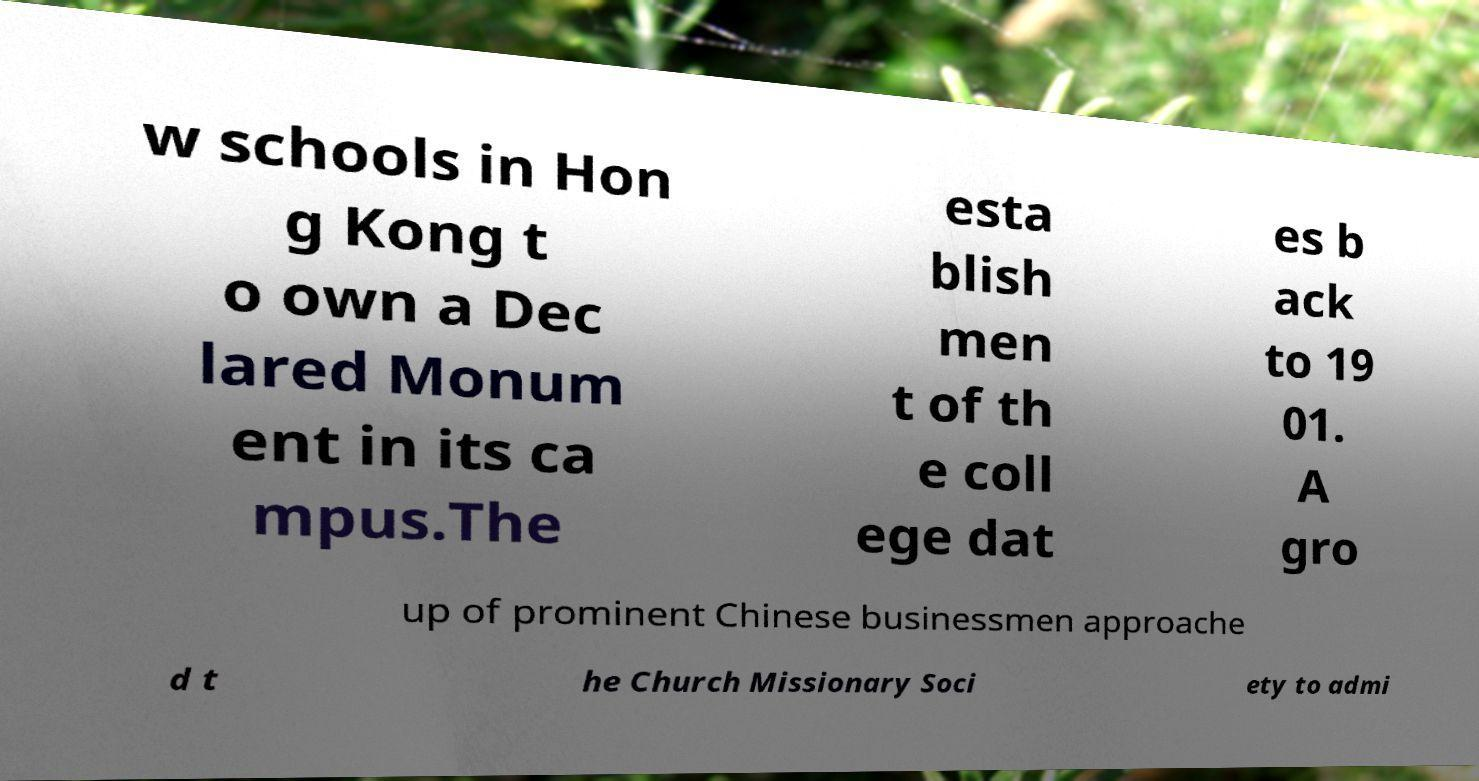Please identify and transcribe the text found in this image. w schools in Hon g Kong t o own a Dec lared Monum ent in its ca mpus.The esta blish men t of th e coll ege dat es b ack to 19 01. A gro up of prominent Chinese businessmen approache d t he Church Missionary Soci ety to admi 